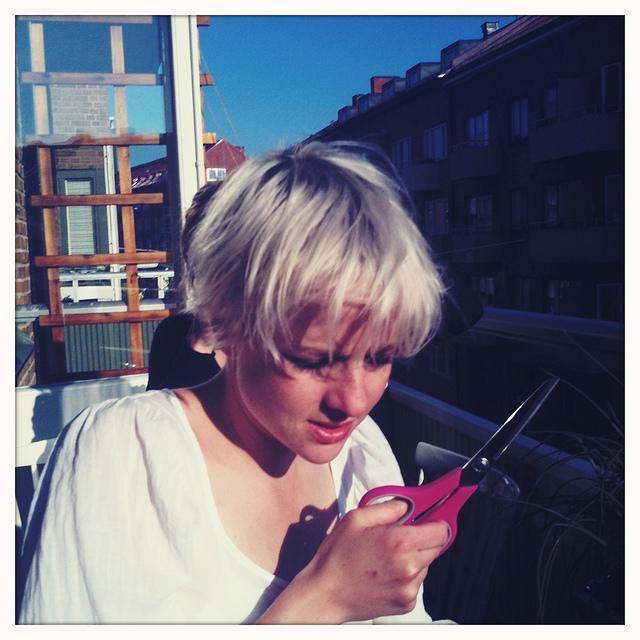How many people are there?
Give a very brief answer. 2. 